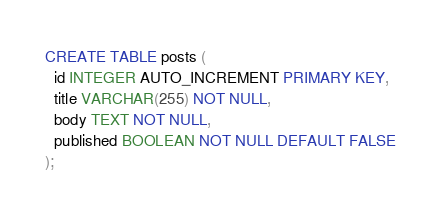<code> <loc_0><loc_0><loc_500><loc_500><_SQL_>CREATE TABLE posts (
  id INTEGER AUTO_INCREMENT PRIMARY KEY,
  title VARCHAR(255) NOT NULL,
  body TEXT NOT NULL,
  published BOOLEAN NOT NULL DEFAULT FALSE
);</code> 